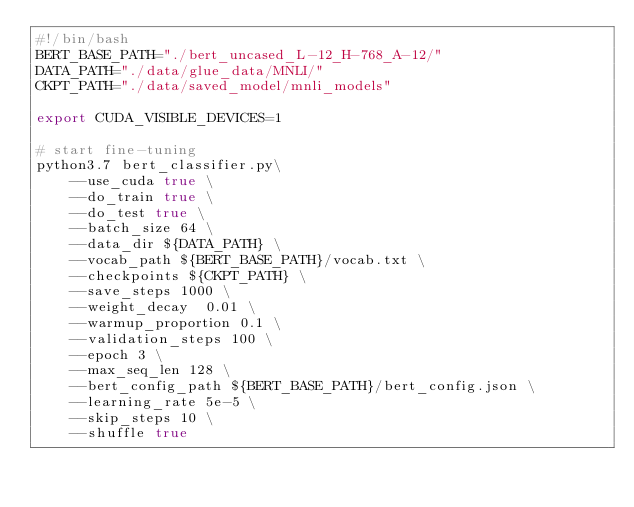Convert code to text. <code><loc_0><loc_0><loc_500><loc_500><_Bash_>#!/bin/bash
BERT_BASE_PATH="./bert_uncased_L-12_H-768_A-12/"
DATA_PATH="./data/glue_data/MNLI/"
CKPT_PATH="./data/saved_model/mnli_models"

export CUDA_VISIBLE_DEVICES=1

# start fine-tuning
python3.7 bert_classifier.py\
    --use_cuda true \
    --do_train true \
    --do_test true \
    --batch_size 64 \
    --data_dir ${DATA_PATH} \
    --vocab_path ${BERT_BASE_PATH}/vocab.txt \
    --checkpoints ${CKPT_PATH} \
    --save_steps 1000 \
    --weight_decay  0.01 \
    --warmup_proportion 0.1 \
    --validation_steps 100 \
    --epoch 3 \
    --max_seq_len 128 \
    --bert_config_path ${BERT_BASE_PATH}/bert_config.json \
    --learning_rate 5e-5 \
    --skip_steps 10 \
    --shuffle true

</code> 